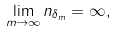<formula> <loc_0><loc_0><loc_500><loc_500>\lim _ { m \to \infty } n _ { \delta _ { m } } = \infty ,</formula> 